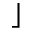<formula> <loc_0><loc_0><loc_500><loc_500>\rfloor</formula> 